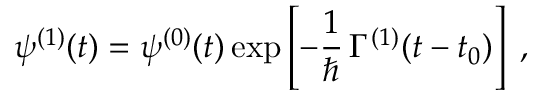<formula> <loc_0><loc_0><loc_500><loc_500>\psi ^ { ( 1 ) } ( t ) = \psi ^ { ( 0 ) } ( t ) \exp \left [ - \frac { 1 } { } \, \Gamma ^ { ( 1 ) } ( t - t _ { 0 } ) \right ] \, ,</formula> 